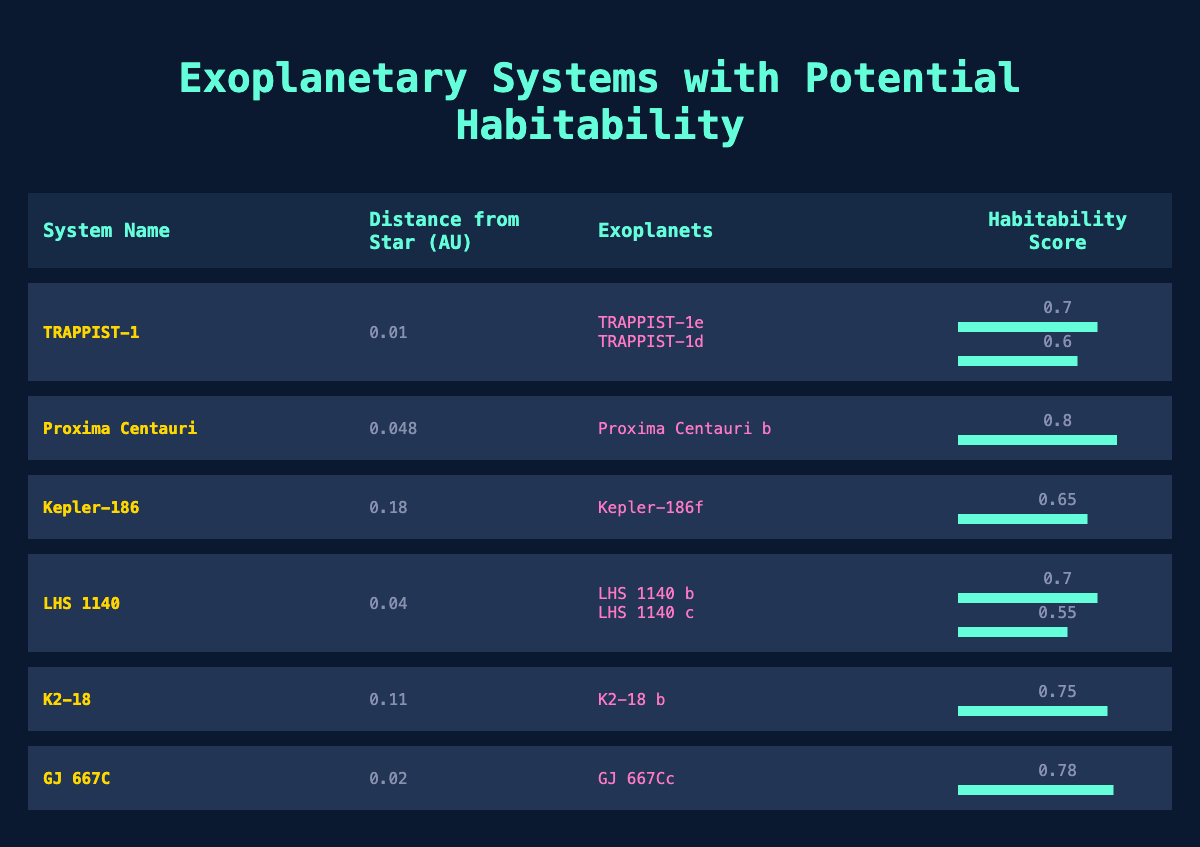What is the habitability score of TRAPPIST-1e? From the table, the habitability score for TRAPPIST-1e is listed as 0.7 in the corresponding row.
Answer: 0.7 Which exoplanet has the highest habitability score? By examining the table, the habitability scores are 0.7 for TRAPPIST-1e, 0.6 for TRAPPIST-1d, 0.8 for Proxima Centauri b, 0.65 for Kepler-186f, 0.7 for LHS 1140 b, 0.55 for LHS 1140 c, 0.75 for K2-18 b, and 0.78 for GJ 667Cc. The highest score is 0.8 for Proxima Centauri b.
Answer: Proxima Centauri b Which system has more than two planets? The table lists TRAPPIST-1 and LHS 1140 as having more than one planet each, but both only have two. No system has more than two planets.
Answer: No What is the average habitability score of the exoplanets listed in the K2-18 system? K2-18 system has one exoplanet, K2-18 b, with a habitability score of 0.75. Since there is only one value, the average is that same value: (0.75)/1 = 0.75.
Answer: 0.75 Is the distance from star for GJ 667C less than 0.05 AU? The distance listed for GJ 667C is 0.02 AU, which is less than 0.05 AU. Thus, the answer is true.
Answer: Yes Which planetary system has the second highest habitability score, and what is that score? From the table, Proxima Centauri has the highest score at 0.8. The next highest is GJ 667C at 0.78, making it the second highest.
Answer: GJ 667C, 0.78 What is the combined habitability score for the exoplanets in the TRAPPIST-1 system? TRAPPIST-1 has two planets with scores of 0.7 for TRAPPIST-1e and 0.6 for TRAPPIST-1d. The combined score is calculated by adding them: 0.7 + 0.6 = 1.3.
Answer: 1.3 What is the distance from star for LHS 1140? The distance from the star for LHS 1140 is stated as 0.04 AU in the table.
Answer: 0.04 AU How many exoplanets listed have a habitability score above 0.7? The exoplanets with scores above 0.7 are TRAPPIST-1e (0.7), Proxima Centauri b (0.8), GJ 667Cc (0.78), and K2-18 b (0.75). This means there are four distinct planets with scores above 0.7.
Answer: 4 